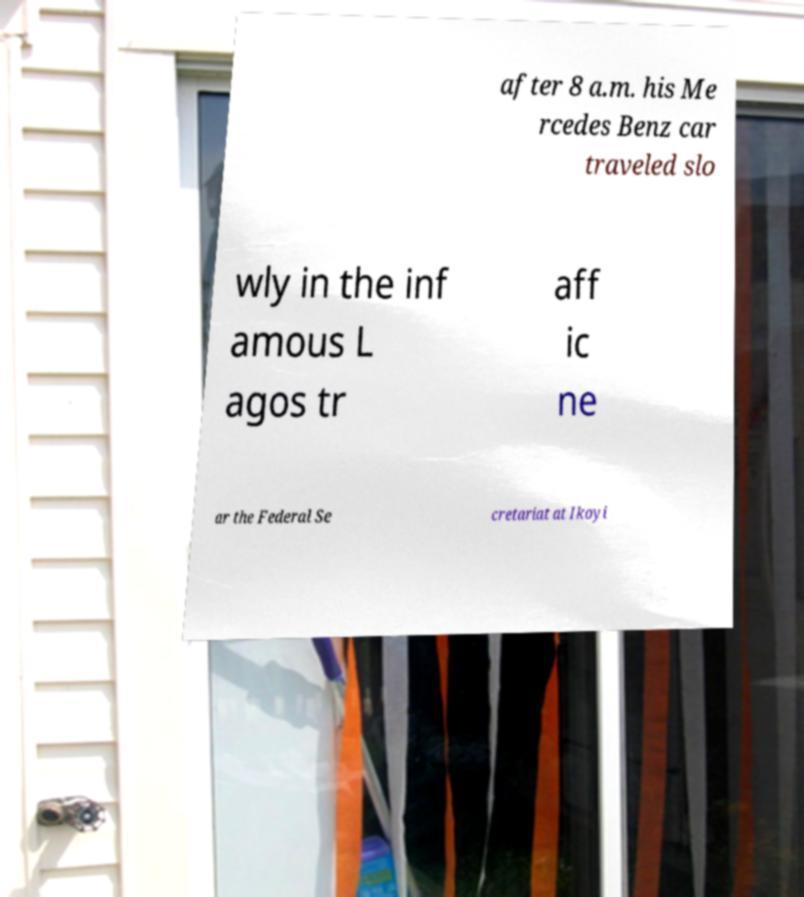Could you extract and type out the text from this image? after 8 a.m. his Me rcedes Benz car traveled slo wly in the inf amous L agos tr aff ic ne ar the Federal Se cretariat at Ikoyi 